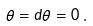Convert formula to latex. <formula><loc_0><loc_0><loc_500><loc_500>\theta = d \theta = 0 \, .</formula> 